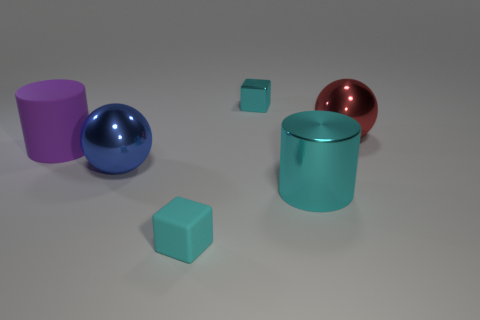What is the texture of the objects? The objects displayed in the image all have a smooth and shiny surface, suggesting a metallic texture. 